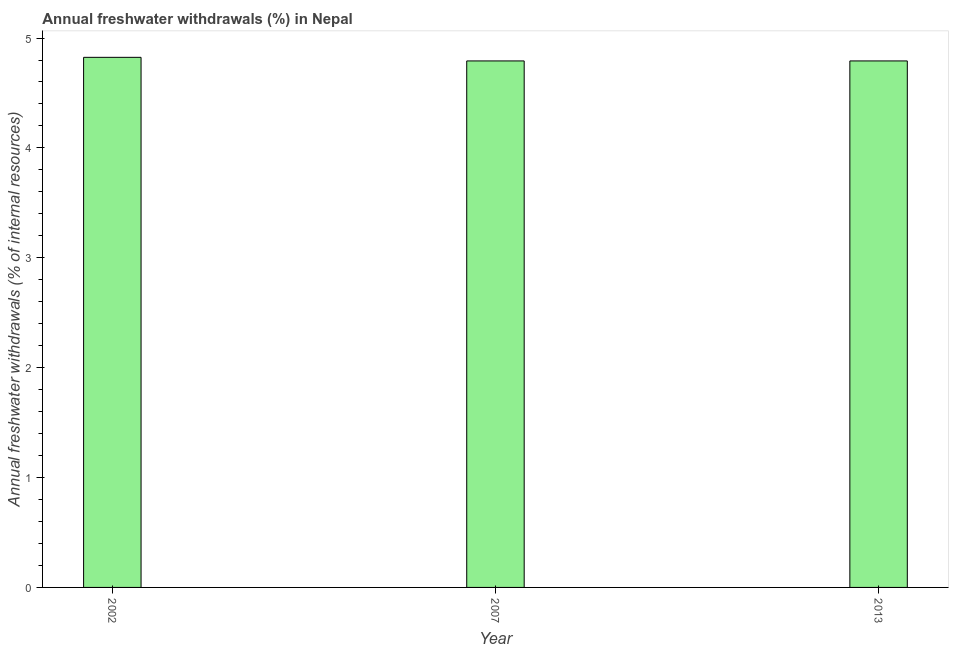Does the graph contain any zero values?
Make the answer very short. No. What is the title of the graph?
Provide a succinct answer. Annual freshwater withdrawals (%) in Nepal. What is the label or title of the X-axis?
Offer a very short reply. Year. What is the label or title of the Y-axis?
Your answer should be very brief. Annual freshwater withdrawals (% of internal resources). What is the annual freshwater withdrawals in 2013?
Provide a succinct answer. 4.79. Across all years, what is the maximum annual freshwater withdrawals?
Offer a very short reply. 4.82. Across all years, what is the minimum annual freshwater withdrawals?
Make the answer very short. 4.79. What is the sum of the annual freshwater withdrawals?
Make the answer very short. 14.41. What is the average annual freshwater withdrawals per year?
Your response must be concise. 4.8. What is the median annual freshwater withdrawals?
Give a very brief answer. 4.79. Do a majority of the years between 2002 and 2007 (inclusive) have annual freshwater withdrawals greater than 3.8 %?
Provide a succinct answer. Yes. Is the difference between the annual freshwater withdrawals in 2007 and 2013 greater than the difference between any two years?
Your response must be concise. No. What is the difference between the highest and the second highest annual freshwater withdrawals?
Offer a terse response. 0.03. Is the sum of the annual freshwater withdrawals in 2002 and 2013 greater than the maximum annual freshwater withdrawals across all years?
Your answer should be very brief. Yes. In how many years, is the annual freshwater withdrawals greater than the average annual freshwater withdrawals taken over all years?
Make the answer very short. 1. How many bars are there?
Provide a succinct answer. 3. Are all the bars in the graph horizontal?
Offer a very short reply. No. How many years are there in the graph?
Keep it short and to the point. 3. What is the difference between two consecutive major ticks on the Y-axis?
Provide a short and direct response. 1. What is the Annual freshwater withdrawals (% of internal resources) of 2002?
Ensure brevity in your answer.  4.82. What is the Annual freshwater withdrawals (% of internal resources) in 2007?
Keep it short and to the point. 4.79. What is the Annual freshwater withdrawals (% of internal resources) in 2013?
Your answer should be compact. 4.79. What is the difference between the Annual freshwater withdrawals (% of internal resources) in 2002 and 2007?
Provide a succinct answer. 0.03. What is the difference between the Annual freshwater withdrawals (% of internal resources) in 2002 and 2013?
Your answer should be very brief. 0.03. What is the difference between the Annual freshwater withdrawals (% of internal resources) in 2007 and 2013?
Provide a short and direct response. 0. What is the ratio of the Annual freshwater withdrawals (% of internal resources) in 2002 to that in 2007?
Your answer should be compact. 1.01. What is the ratio of the Annual freshwater withdrawals (% of internal resources) in 2002 to that in 2013?
Make the answer very short. 1.01. What is the ratio of the Annual freshwater withdrawals (% of internal resources) in 2007 to that in 2013?
Give a very brief answer. 1. 